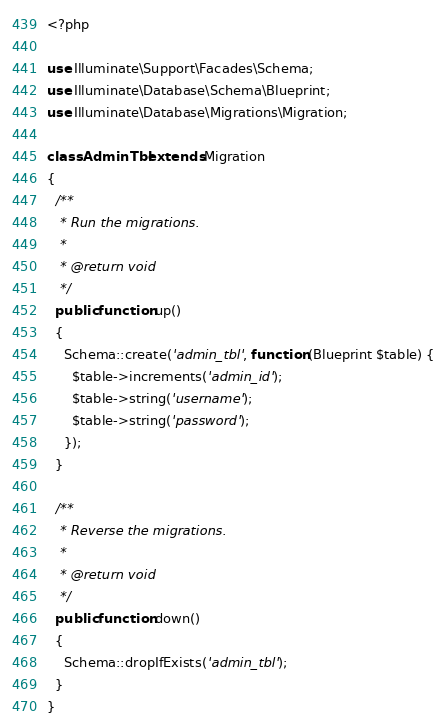Convert code to text. <code><loc_0><loc_0><loc_500><loc_500><_PHP_><?php

use Illuminate\Support\Facades\Schema;
use Illuminate\Database\Schema\Blueprint;
use Illuminate\Database\Migrations\Migration;

class AdminTbl extends Migration
{
  /**
   * Run the migrations.
   *
   * @return void
   */
  public function up()
  {
    Schema::create('admin_tbl', function (Blueprint $table) {
      $table->increments('admin_id');
      $table->string('username');
      $table->string('password');
    });
  }

  /**
   * Reverse the migrations.
   *
   * @return void
   */
  public function down()
  {
    Schema::dropIfExists('admin_tbl');
  }
}
</code> 